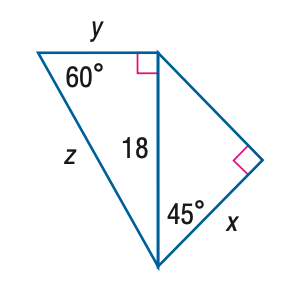Question: Find y.
Choices:
A. 9
B. 6 \sqrt { 3 }
C. 18
D. 18 \sqrt { 3 }
Answer with the letter. Answer: B Question: Find z.
Choices:
A. 6 \sqrt { 3 }
B. 12 \sqrt { 3 }
C. 18 \sqrt { 2 }
D. 36
Answer with the letter. Answer: B Question: Find x.
Choices:
A. 9
B. 9 \sqrt { 2 }
C. 9 \sqrt { 3 }
D. 18 \sqrt { 2 }
Answer with the letter. Answer: B 